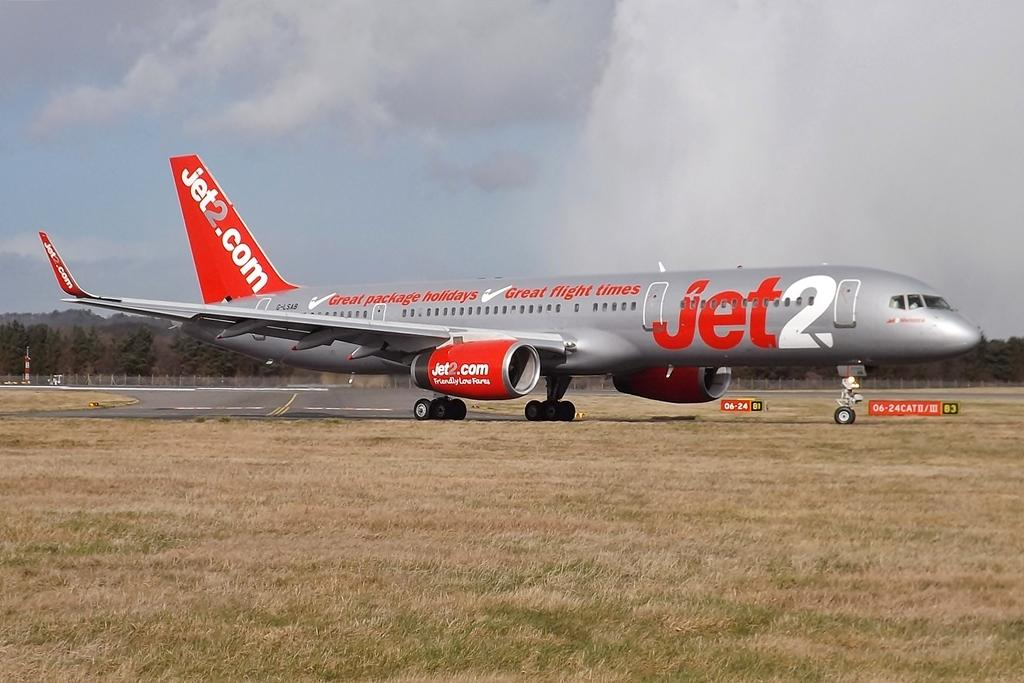<image>
Summarize the visual content of the image. A red and silver colored Jet2 airplane is on the runway. 